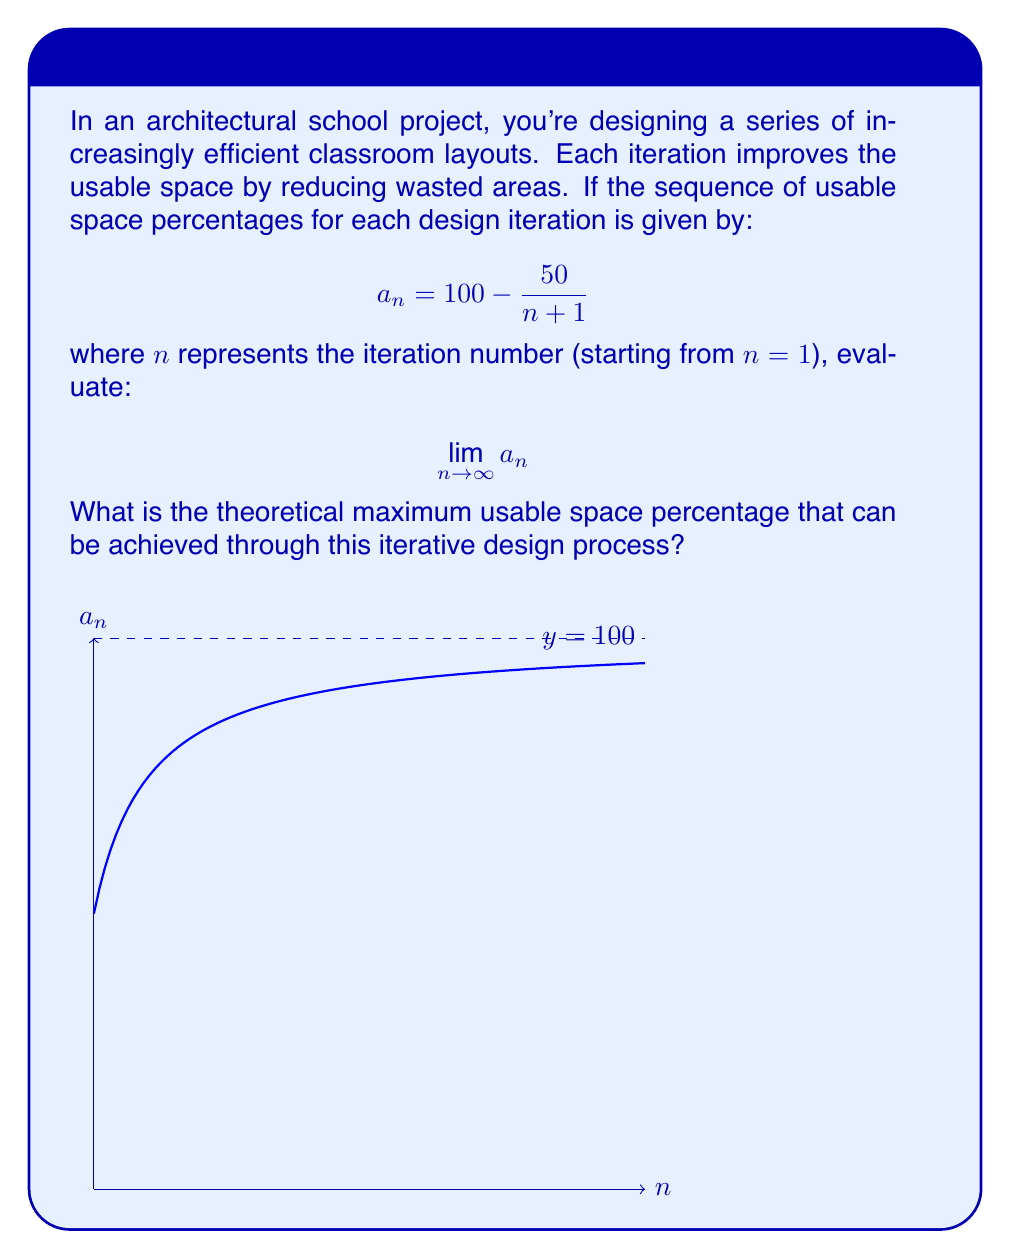Teach me how to tackle this problem. Let's approach this step-by-step:

1) We start with the given sequence:
   $$a_n = 100 - \frac{50}{n+1}$$

2) To evaluate the limit as $n$ approaches infinity, we need to consider what happens to the fraction $\frac{50}{n+1}$ as $n$ gets very large.

3) As $n \to \infty$, $(n+1)$ also approaches infinity.

4) When a constant (in this case, 50) is divided by a value approaching infinity, the result approaches zero:
   $$\lim_{n \to \infty} \frac{50}{n+1} = 0$$

5) Now, let's apply this to our original sequence:
   $$\lim_{n \to \infty} a_n = \lim_{n \to \infty} (100 - \frac{50}{n+1})$$

6) We can split this limit:
   $$= 100 - \lim_{n \to \infty} \frac{50}{n+1}$$

7) From step 4, we know that the limit of $\frac{50}{n+1}$ is 0, so:
   $$= 100 - 0 = 100$$

Therefore, the theoretical maximum usable space percentage that can be achieved through this iterative design process is 100%.
Answer: 100% 